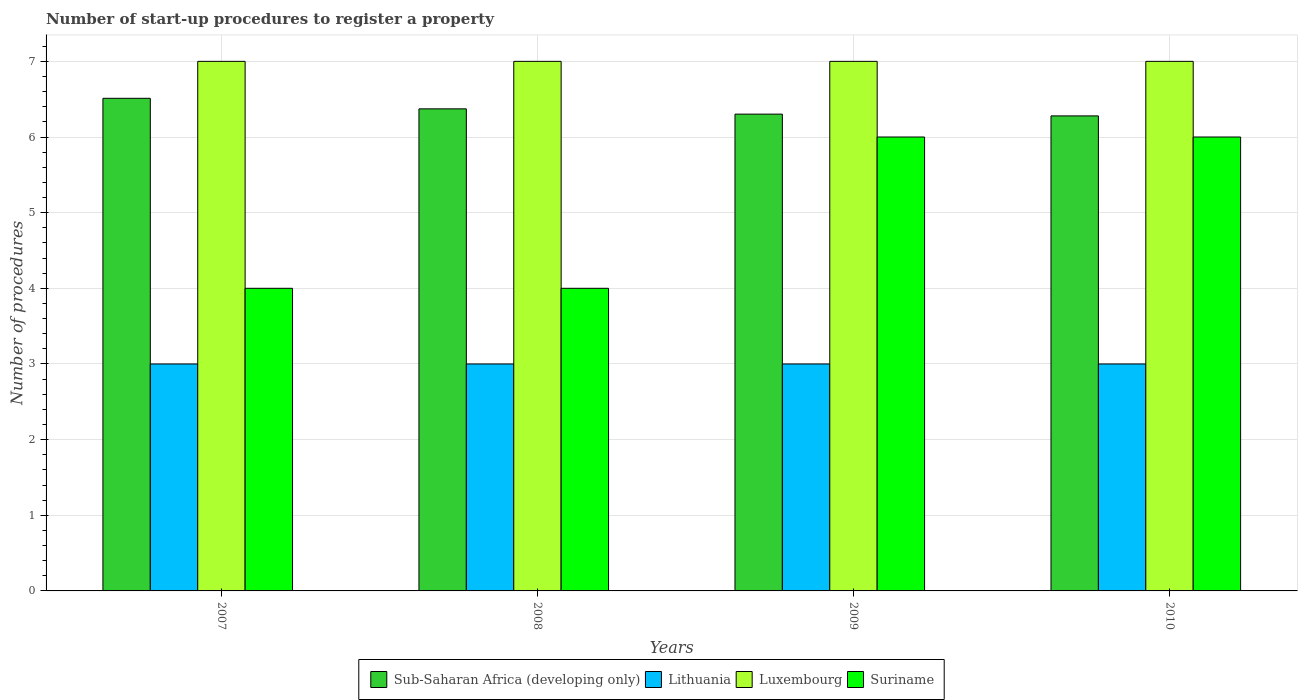How many groups of bars are there?
Give a very brief answer. 4. What is the number of procedures required to register a property in Luxembourg in 2010?
Your answer should be very brief. 7. Across all years, what is the maximum number of procedures required to register a property in Sub-Saharan Africa (developing only)?
Ensure brevity in your answer.  6.51. Across all years, what is the minimum number of procedures required to register a property in Lithuania?
Provide a short and direct response. 3. In which year was the number of procedures required to register a property in Suriname maximum?
Provide a succinct answer. 2009. What is the total number of procedures required to register a property in Lithuania in the graph?
Offer a terse response. 12. What is the difference between the number of procedures required to register a property in Sub-Saharan Africa (developing only) in 2009 and that in 2010?
Offer a very short reply. 0.02. What is the average number of procedures required to register a property in Suriname per year?
Make the answer very short. 5. In the year 2008, what is the difference between the number of procedures required to register a property in Lithuania and number of procedures required to register a property in Luxembourg?
Offer a very short reply. -4. What is the ratio of the number of procedures required to register a property in Luxembourg in 2008 to that in 2010?
Keep it short and to the point. 1. Is the number of procedures required to register a property in Luxembourg in 2007 less than that in 2008?
Give a very brief answer. No. Is the difference between the number of procedures required to register a property in Lithuania in 2007 and 2010 greater than the difference between the number of procedures required to register a property in Luxembourg in 2007 and 2010?
Keep it short and to the point. No. What is the difference between the highest and the second highest number of procedures required to register a property in Luxembourg?
Keep it short and to the point. 0. Is the sum of the number of procedures required to register a property in Luxembourg in 2007 and 2008 greater than the maximum number of procedures required to register a property in Sub-Saharan Africa (developing only) across all years?
Make the answer very short. Yes. What does the 3rd bar from the left in 2010 represents?
Offer a terse response. Luxembourg. What does the 4th bar from the right in 2007 represents?
Offer a very short reply. Sub-Saharan Africa (developing only). Is it the case that in every year, the sum of the number of procedures required to register a property in Sub-Saharan Africa (developing only) and number of procedures required to register a property in Suriname is greater than the number of procedures required to register a property in Luxembourg?
Your answer should be very brief. Yes. How many bars are there?
Provide a succinct answer. 16. Does the graph contain any zero values?
Give a very brief answer. No. Does the graph contain grids?
Keep it short and to the point. Yes. Where does the legend appear in the graph?
Provide a succinct answer. Bottom center. How many legend labels are there?
Give a very brief answer. 4. How are the legend labels stacked?
Give a very brief answer. Horizontal. What is the title of the graph?
Offer a very short reply. Number of start-up procedures to register a property. What is the label or title of the Y-axis?
Offer a very short reply. Number of procedures. What is the Number of procedures of Sub-Saharan Africa (developing only) in 2007?
Ensure brevity in your answer.  6.51. What is the Number of procedures in Lithuania in 2007?
Provide a short and direct response. 3. What is the Number of procedures of Luxembourg in 2007?
Offer a very short reply. 7. What is the Number of procedures of Suriname in 2007?
Provide a succinct answer. 4. What is the Number of procedures of Sub-Saharan Africa (developing only) in 2008?
Provide a succinct answer. 6.37. What is the Number of procedures in Lithuania in 2008?
Your answer should be compact. 3. What is the Number of procedures in Luxembourg in 2008?
Give a very brief answer. 7. What is the Number of procedures of Suriname in 2008?
Your answer should be very brief. 4. What is the Number of procedures in Sub-Saharan Africa (developing only) in 2009?
Offer a very short reply. 6.3. What is the Number of procedures in Lithuania in 2009?
Give a very brief answer. 3. What is the Number of procedures in Luxembourg in 2009?
Provide a short and direct response. 7. What is the Number of procedures of Sub-Saharan Africa (developing only) in 2010?
Your answer should be very brief. 6.28. What is the Number of procedures of Lithuania in 2010?
Provide a succinct answer. 3. Across all years, what is the maximum Number of procedures of Sub-Saharan Africa (developing only)?
Provide a succinct answer. 6.51. Across all years, what is the maximum Number of procedures of Suriname?
Provide a succinct answer. 6. Across all years, what is the minimum Number of procedures in Sub-Saharan Africa (developing only)?
Offer a terse response. 6.28. What is the total Number of procedures of Sub-Saharan Africa (developing only) in the graph?
Ensure brevity in your answer.  25.47. What is the total Number of procedures in Lithuania in the graph?
Ensure brevity in your answer.  12. What is the total Number of procedures of Luxembourg in the graph?
Offer a very short reply. 28. What is the difference between the Number of procedures in Sub-Saharan Africa (developing only) in 2007 and that in 2008?
Provide a short and direct response. 0.14. What is the difference between the Number of procedures in Sub-Saharan Africa (developing only) in 2007 and that in 2009?
Your answer should be very brief. 0.21. What is the difference between the Number of procedures in Suriname in 2007 and that in 2009?
Give a very brief answer. -2. What is the difference between the Number of procedures in Sub-Saharan Africa (developing only) in 2007 and that in 2010?
Your answer should be very brief. 0.23. What is the difference between the Number of procedures of Sub-Saharan Africa (developing only) in 2008 and that in 2009?
Your answer should be compact. 0.07. What is the difference between the Number of procedures of Lithuania in 2008 and that in 2009?
Provide a short and direct response. 0. What is the difference between the Number of procedures of Suriname in 2008 and that in 2009?
Your answer should be very brief. -2. What is the difference between the Number of procedures in Sub-Saharan Africa (developing only) in 2008 and that in 2010?
Offer a terse response. 0.09. What is the difference between the Number of procedures in Sub-Saharan Africa (developing only) in 2009 and that in 2010?
Provide a succinct answer. 0.02. What is the difference between the Number of procedures in Lithuania in 2009 and that in 2010?
Make the answer very short. 0. What is the difference between the Number of procedures in Luxembourg in 2009 and that in 2010?
Your response must be concise. 0. What is the difference between the Number of procedures of Suriname in 2009 and that in 2010?
Ensure brevity in your answer.  0. What is the difference between the Number of procedures in Sub-Saharan Africa (developing only) in 2007 and the Number of procedures in Lithuania in 2008?
Your response must be concise. 3.51. What is the difference between the Number of procedures in Sub-Saharan Africa (developing only) in 2007 and the Number of procedures in Luxembourg in 2008?
Your answer should be compact. -0.49. What is the difference between the Number of procedures in Sub-Saharan Africa (developing only) in 2007 and the Number of procedures in Suriname in 2008?
Offer a very short reply. 2.51. What is the difference between the Number of procedures of Lithuania in 2007 and the Number of procedures of Suriname in 2008?
Your answer should be very brief. -1. What is the difference between the Number of procedures in Luxembourg in 2007 and the Number of procedures in Suriname in 2008?
Ensure brevity in your answer.  3. What is the difference between the Number of procedures of Sub-Saharan Africa (developing only) in 2007 and the Number of procedures of Lithuania in 2009?
Offer a terse response. 3.51. What is the difference between the Number of procedures in Sub-Saharan Africa (developing only) in 2007 and the Number of procedures in Luxembourg in 2009?
Make the answer very short. -0.49. What is the difference between the Number of procedures in Sub-Saharan Africa (developing only) in 2007 and the Number of procedures in Suriname in 2009?
Your answer should be compact. 0.51. What is the difference between the Number of procedures in Lithuania in 2007 and the Number of procedures in Luxembourg in 2009?
Offer a terse response. -4. What is the difference between the Number of procedures of Sub-Saharan Africa (developing only) in 2007 and the Number of procedures of Lithuania in 2010?
Your response must be concise. 3.51. What is the difference between the Number of procedures of Sub-Saharan Africa (developing only) in 2007 and the Number of procedures of Luxembourg in 2010?
Your answer should be compact. -0.49. What is the difference between the Number of procedures in Sub-Saharan Africa (developing only) in 2007 and the Number of procedures in Suriname in 2010?
Your answer should be compact. 0.51. What is the difference between the Number of procedures in Luxembourg in 2007 and the Number of procedures in Suriname in 2010?
Provide a short and direct response. 1. What is the difference between the Number of procedures in Sub-Saharan Africa (developing only) in 2008 and the Number of procedures in Lithuania in 2009?
Give a very brief answer. 3.37. What is the difference between the Number of procedures of Sub-Saharan Africa (developing only) in 2008 and the Number of procedures of Luxembourg in 2009?
Your answer should be compact. -0.63. What is the difference between the Number of procedures in Sub-Saharan Africa (developing only) in 2008 and the Number of procedures in Suriname in 2009?
Your answer should be very brief. 0.37. What is the difference between the Number of procedures of Lithuania in 2008 and the Number of procedures of Luxembourg in 2009?
Keep it short and to the point. -4. What is the difference between the Number of procedures of Sub-Saharan Africa (developing only) in 2008 and the Number of procedures of Lithuania in 2010?
Your response must be concise. 3.37. What is the difference between the Number of procedures of Sub-Saharan Africa (developing only) in 2008 and the Number of procedures of Luxembourg in 2010?
Offer a very short reply. -0.63. What is the difference between the Number of procedures in Sub-Saharan Africa (developing only) in 2008 and the Number of procedures in Suriname in 2010?
Provide a short and direct response. 0.37. What is the difference between the Number of procedures of Lithuania in 2008 and the Number of procedures of Luxembourg in 2010?
Make the answer very short. -4. What is the difference between the Number of procedures of Sub-Saharan Africa (developing only) in 2009 and the Number of procedures of Lithuania in 2010?
Ensure brevity in your answer.  3.3. What is the difference between the Number of procedures of Sub-Saharan Africa (developing only) in 2009 and the Number of procedures of Luxembourg in 2010?
Your answer should be very brief. -0.7. What is the difference between the Number of procedures in Sub-Saharan Africa (developing only) in 2009 and the Number of procedures in Suriname in 2010?
Ensure brevity in your answer.  0.3. What is the difference between the Number of procedures of Lithuania in 2009 and the Number of procedures of Suriname in 2010?
Offer a terse response. -3. What is the difference between the Number of procedures of Luxembourg in 2009 and the Number of procedures of Suriname in 2010?
Offer a terse response. 1. What is the average Number of procedures in Sub-Saharan Africa (developing only) per year?
Ensure brevity in your answer.  6.37. In the year 2007, what is the difference between the Number of procedures in Sub-Saharan Africa (developing only) and Number of procedures in Lithuania?
Keep it short and to the point. 3.51. In the year 2007, what is the difference between the Number of procedures in Sub-Saharan Africa (developing only) and Number of procedures in Luxembourg?
Provide a short and direct response. -0.49. In the year 2007, what is the difference between the Number of procedures in Sub-Saharan Africa (developing only) and Number of procedures in Suriname?
Provide a short and direct response. 2.51. In the year 2008, what is the difference between the Number of procedures of Sub-Saharan Africa (developing only) and Number of procedures of Lithuania?
Your answer should be compact. 3.37. In the year 2008, what is the difference between the Number of procedures in Sub-Saharan Africa (developing only) and Number of procedures in Luxembourg?
Offer a very short reply. -0.63. In the year 2008, what is the difference between the Number of procedures in Sub-Saharan Africa (developing only) and Number of procedures in Suriname?
Provide a short and direct response. 2.37. In the year 2008, what is the difference between the Number of procedures in Lithuania and Number of procedures in Suriname?
Offer a very short reply. -1. In the year 2009, what is the difference between the Number of procedures of Sub-Saharan Africa (developing only) and Number of procedures of Lithuania?
Your answer should be compact. 3.3. In the year 2009, what is the difference between the Number of procedures in Sub-Saharan Africa (developing only) and Number of procedures in Luxembourg?
Give a very brief answer. -0.7. In the year 2009, what is the difference between the Number of procedures in Sub-Saharan Africa (developing only) and Number of procedures in Suriname?
Offer a terse response. 0.3. In the year 2010, what is the difference between the Number of procedures in Sub-Saharan Africa (developing only) and Number of procedures in Lithuania?
Make the answer very short. 3.28. In the year 2010, what is the difference between the Number of procedures in Sub-Saharan Africa (developing only) and Number of procedures in Luxembourg?
Your answer should be very brief. -0.72. In the year 2010, what is the difference between the Number of procedures of Sub-Saharan Africa (developing only) and Number of procedures of Suriname?
Provide a short and direct response. 0.28. In the year 2010, what is the difference between the Number of procedures of Lithuania and Number of procedures of Suriname?
Ensure brevity in your answer.  -3. What is the ratio of the Number of procedures of Sub-Saharan Africa (developing only) in 2007 to that in 2008?
Your answer should be compact. 1.02. What is the ratio of the Number of procedures of Lithuania in 2007 to that in 2008?
Your response must be concise. 1. What is the ratio of the Number of procedures of Luxembourg in 2007 to that in 2008?
Offer a terse response. 1. What is the ratio of the Number of procedures of Suriname in 2007 to that in 2008?
Your answer should be very brief. 1. What is the ratio of the Number of procedures of Sub-Saharan Africa (developing only) in 2007 to that in 2009?
Your answer should be very brief. 1.03. What is the ratio of the Number of procedures of Luxembourg in 2007 to that in 2009?
Give a very brief answer. 1. What is the ratio of the Number of procedures in Suriname in 2007 to that in 2009?
Keep it short and to the point. 0.67. What is the ratio of the Number of procedures of Luxembourg in 2007 to that in 2010?
Your answer should be very brief. 1. What is the ratio of the Number of procedures in Sub-Saharan Africa (developing only) in 2008 to that in 2009?
Provide a succinct answer. 1.01. What is the ratio of the Number of procedures in Lithuania in 2008 to that in 2009?
Give a very brief answer. 1. What is the ratio of the Number of procedures in Sub-Saharan Africa (developing only) in 2008 to that in 2010?
Your answer should be compact. 1.01. What is the ratio of the Number of procedures in Suriname in 2008 to that in 2010?
Your answer should be very brief. 0.67. What is the ratio of the Number of procedures in Lithuania in 2009 to that in 2010?
Your response must be concise. 1. What is the ratio of the Number of procedures of Luxembourg in 2009 to that in 2010?
Provide a short and direct response. 1. What is the difference between the highest and the second highest Number of procedures of Sub-Saharan Africa (developing only)?
Give a very brief answer. 0.14. What is the difference between the highest and the second highest Number of procedures of Suriname?
Give a very brief answer. 0. What is the difference between the highest and the lowest Number of procedures of Sub-Saharan Africa (developing only)?
Ensure brevity in your answer.  0.23. 